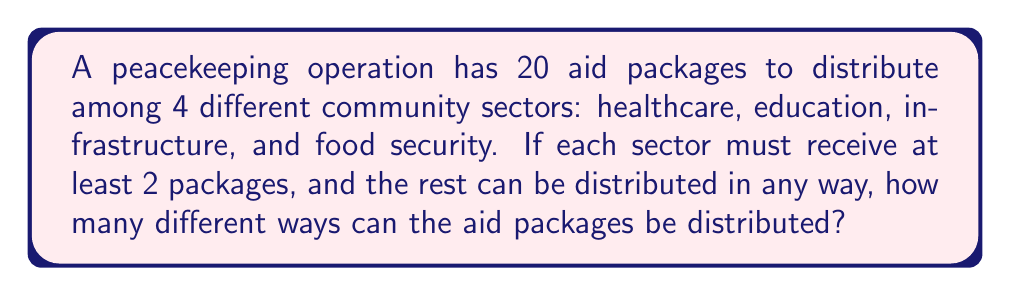What is the answer to this math problem? To solve this problem, we can use the concept of stars and bars (also known as balls and urns) with some modifications. Let's approach this step-by-step:

1) First, we need to ensure each sector gets at least 2 packages. So, we start by allocating 2 packages to each sector:

   Healthcare: 2, Education: 2, Infrastructure: 2, Food Security: 2

2) This leaves us with 20 - (2 * 4) = 12 packages to distribute freely.

3) Now, we can use the stars and bars method to distribute these 12 packages among 4 sectors.

4) The formula for stars and bars is:

   $${n+k-1 \choose k-1}$$

   Where n is the number of identical objects (stars) and k is the number of distinct groups (bars + 1).

5) In our case, n = 12 (remaining packages) and k = 4 (sectors).

6) Plugging into the formula:

   $${12+4-1 \choose 4-1} = {15 \choose 3}$$

7) We can calculate this:

   $${15 \choose 3} = \frac{15!}{3!(15-3)!} = \frac{15!}{3!12!} = \frac{15 * 14 * 13}{3 * 2 * 1} = 455$$

Therefore, there are 455 different ways to distribute the aid packages among the 4 community sectors.
Answer: 455 